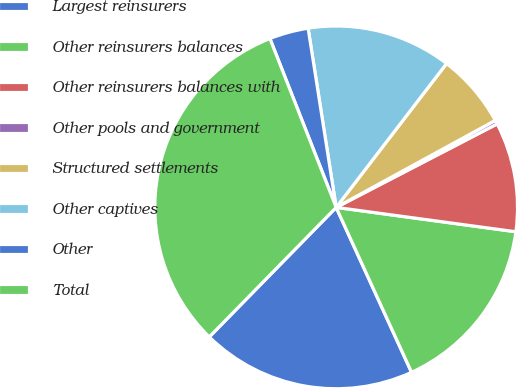Convert chart to OTSL. <chart><loc_0><loc_0><loc_500><loc_500><pie_chart><fcel>Largest reinsurers<fcel>Other reinsurers balances<fcel>Other reinsurers balances with<fcel>Other pools and government<fcel>Structured settlements<fcel>Other captives<fcel>Other<fcel>Total<nl><fcel>19.16%<fcel>16.03%<fcel>9.76%<fcel>0.35%<fcel>6.62%<fcel>12.89%<fcel>3.48%<fcel>31.71%<nl></chart> 